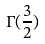Convert formula to latex. <formula><loc_0><loc_0><loc_500><loc_500>\Gamma ( \frac { 3 } { 2 } )</formula> 